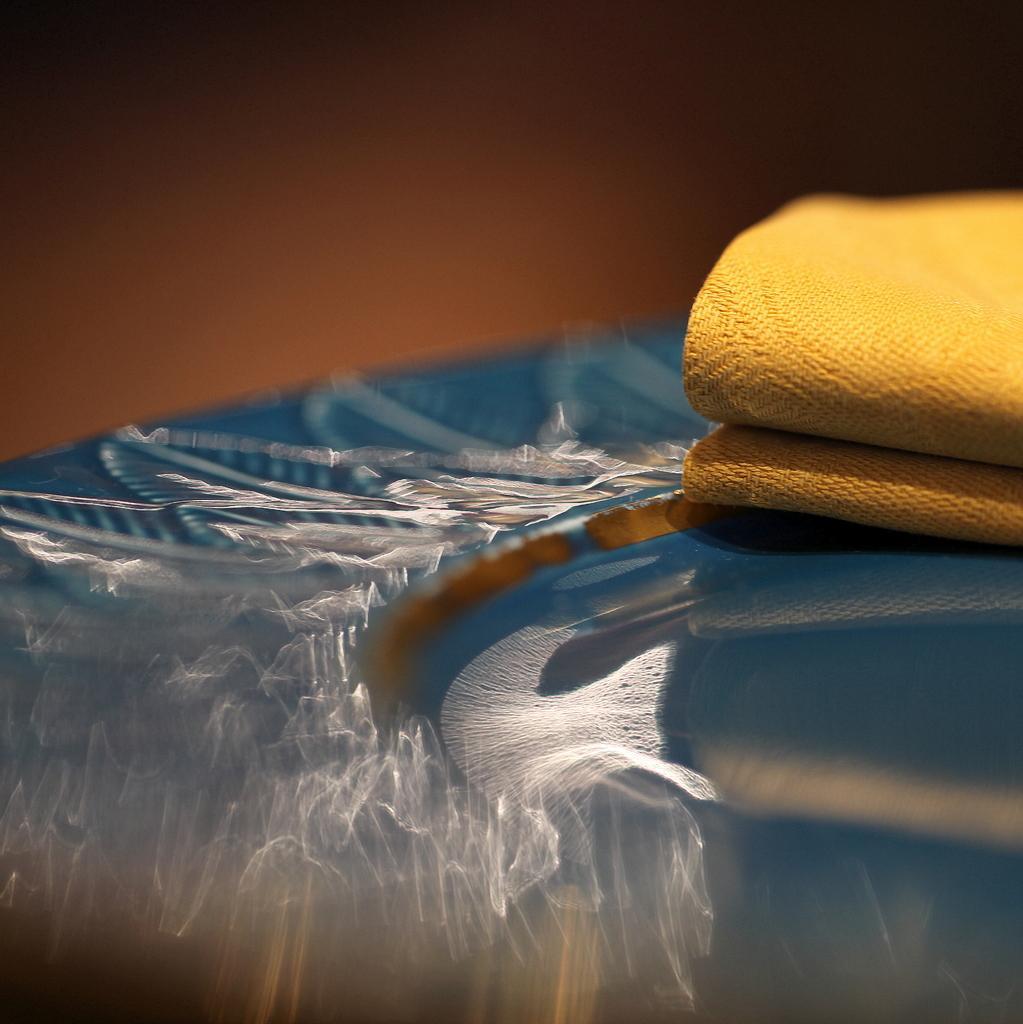Describe this image in one or two sentences. In this image we can see there is a napkin on the plate. 